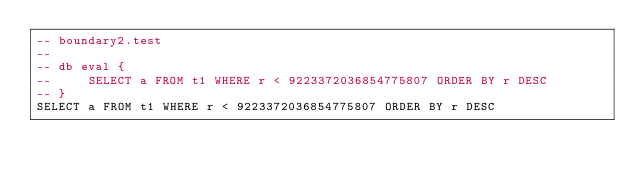Convert code to text. <code><loc_0><loc_0><loc_500><loc_500><_SQL_>-- boundary2.test
-- 
-- db eval {
--     SELECT a FROM t1 WHERE r < 9223372036854775807 ORDER BY r DESC
-- }
SELECT a FROM t1 WHERE r < 9223372036854775807 ORDER BY r DESC</code> 